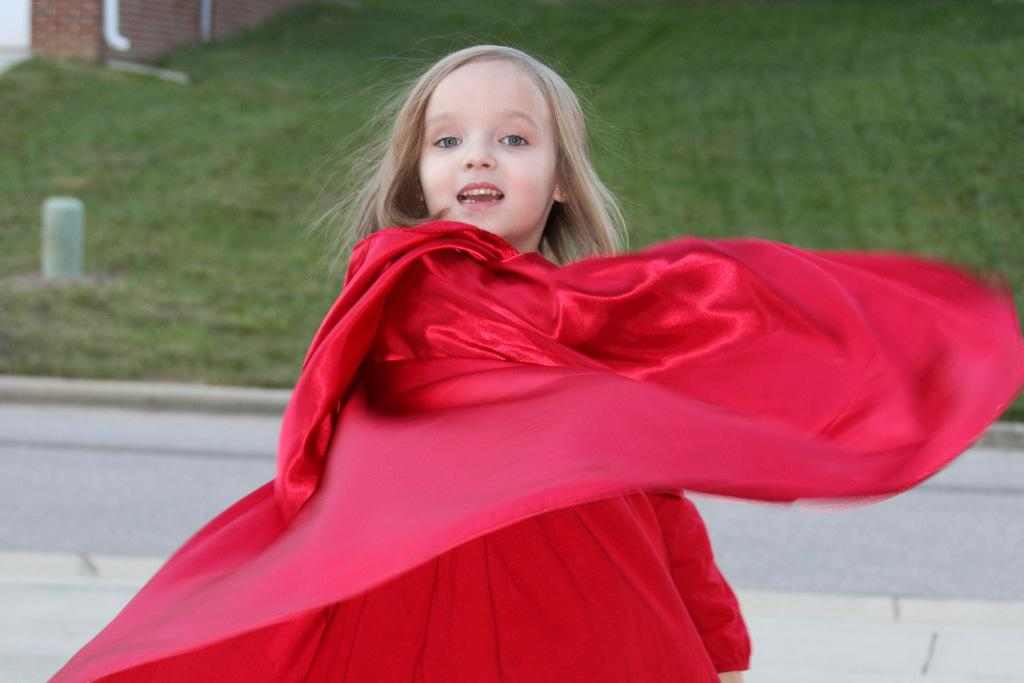Who or what is the main subject in the image? There is a person in the image. What is the person wearing? The person is wearing a red dress. What type of environment is visible in the background of the image? There is grass and a brown color brick wall in the background of the image. What type of thunder can be heard in the image? There is no sound present in the image, so it is not possible to determine if there is any thunder. 